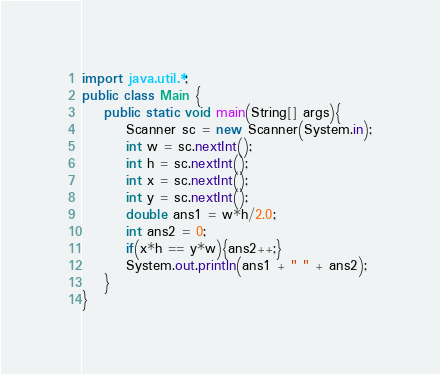<code> <loc_0><loc_0><loc_500><loc_500><_Java_>import java.util.*;
public class Main {
	public static void main(String[] args){
		Scanner sc = new Scanner(System.in);
		int w = sc.nextInt();		
        int h = sc.nextInt();
		int x = sc.nextInt();
        int y = sc.nextInt();
        double ans1 = w*h/2.0;
        int ans2 = 0;
        if(x*h == y*w){ans2++;}
		System.out.println(ans1 + " " + ans2);
	}
}
</code> 